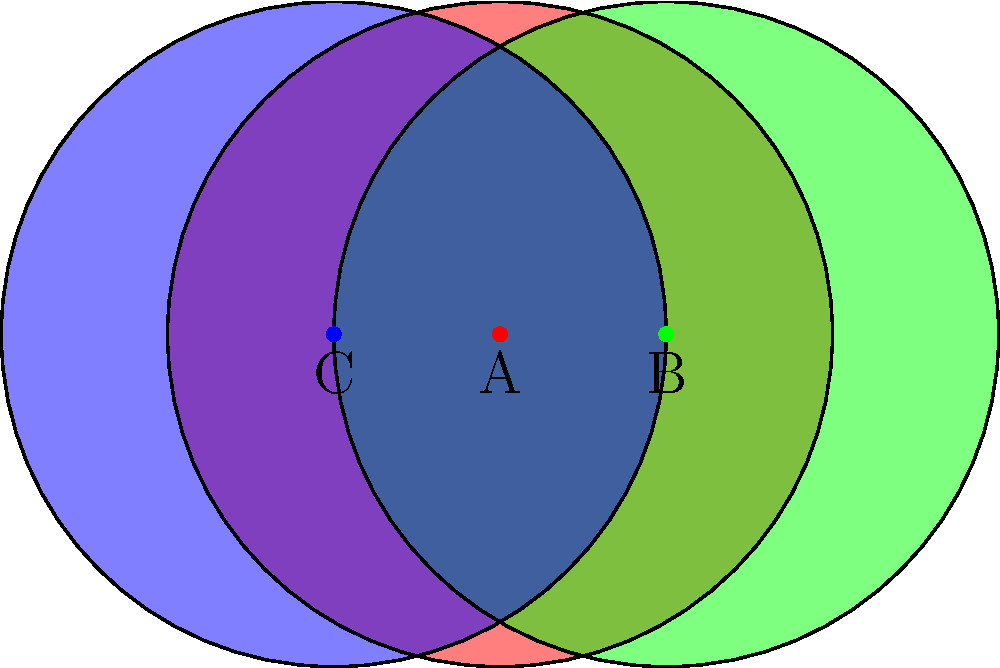In this abstract composition, three translucent color fields (red, green, and blue) overlap to create various regions. Consider the angle formed at point A by the intersections of the red and green circles. What is the measure of this angle? To find the angle at point A, we can follow these steps:

1) First, note that the centers of the circles form an equilateral triangle with side length 0.5 (the distance between the centers).

2) In an equilateral triangle, all angles are 60°.

3) The radius of each circle is 1, which is twice the side length of the equilateral triangle.

4) Consider the triangle formed by the centers of the red and green circles (A and B) and one of the intersection points. This is a right triangle.

5) In this right triangle:
   - The hypotenuse is the radius of the circle, which is 1.
   - One side is half the distance between the centers, which is 0.25.

6) We can find the angle at the center using the cosine function:

   $$\cos(\theta) = \frac{0.25}{1} = 0.25$$

7) Taking the inverse cosine (arccos):

   $$\theta = \arccos(0.25) \approx 75.52°$$

8) This is the angle at the center. The angle we're looking for is the exterior angle, which is twice this:

   $$2 \times 75.52° = 151.04°$$

Therefore, the angle formed at point A by the intersections of the red and green circles is approximately 151.04°.
Answer: 151.04° 